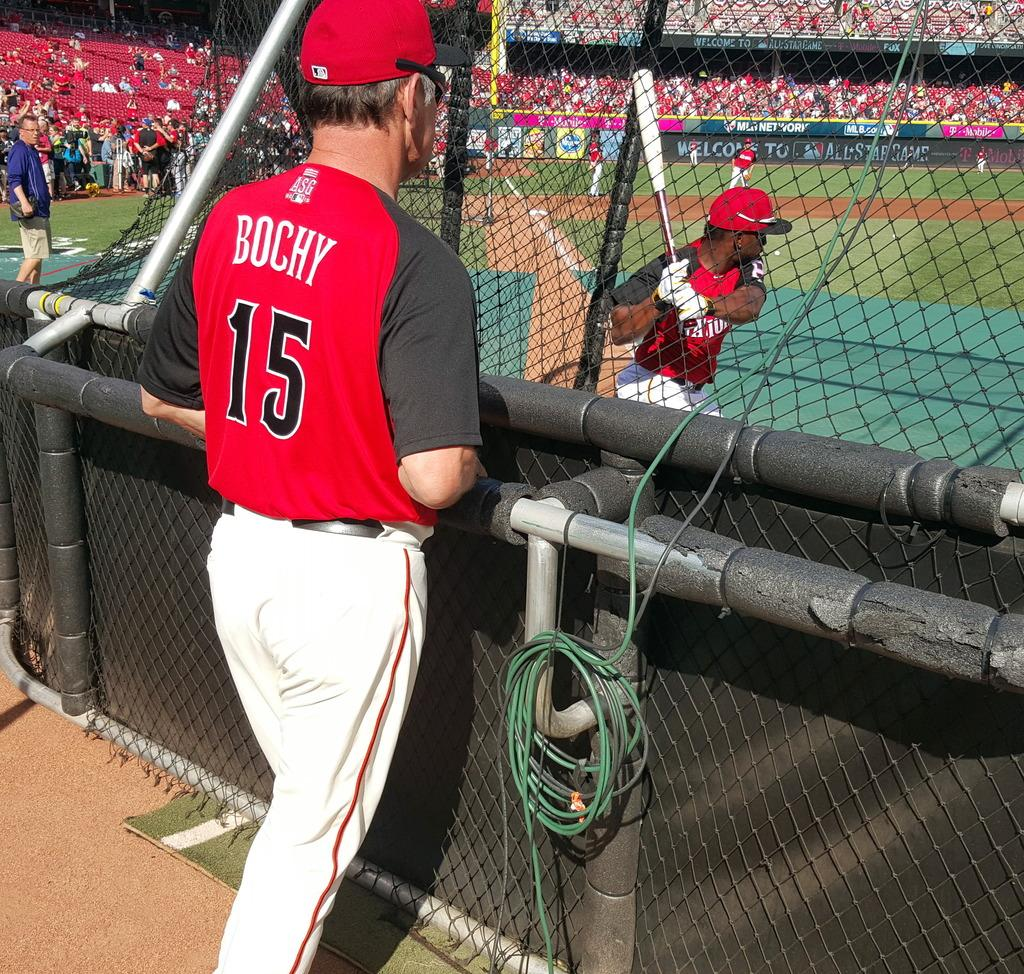<image>
Relay a brief, clear account of the picture shown. a coach that has the number 15 on their jersey 